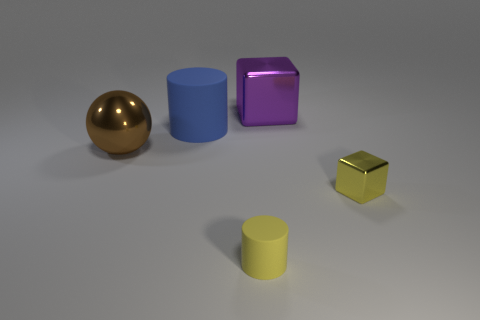Is the number of brown objects behind the large brown thing the same as the number of red cylinders?
Ensure brevity in your answer.  Yes. What material is the small object that is on the right side of the cube that is behind the rubber object behind the large brown sphere made of?
Offer a terse response. Metal. What is the material of the small object that is the same color as the tiny rubber cylinder?
Provide a succinct answer. Metal. What number of things are either metallic blocks in front of the blue object or large brown metallic spheres?
Provide a succinct answer. 2. What number of objects are either large red matte cubes or yellow objects that are left of the small shiny object?
Your response must be concise. 1. How many objects are on the left side of the cylinder that is on the right side of the matte cylinder that is left of the tiny matte cylinder?
Your response must be concise. 2. There is a blue cylinder that is the same size as the purple shiny block; what is it made of?
Your answer should be compact. Rubber. Is there a yellow matte object of the same size as the yellow metallic object?
Offer a very short reply. Yes. The tiny metal cube has what color?
Offer a terse response. Yellow. There is a matte object behind the yellow object that is behind the small cylinder; what color is it?
Ensure brevity in your answer.  Blue. 